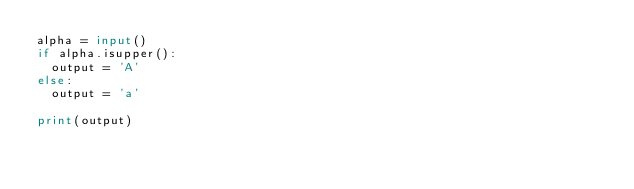<code> <loc_0><loc_0><loc_500><loc_500><_Python_>alpha = input()
if alpha.isupper():
  output = 'A'
else:
  output = 'a'

print(output)
</code> 